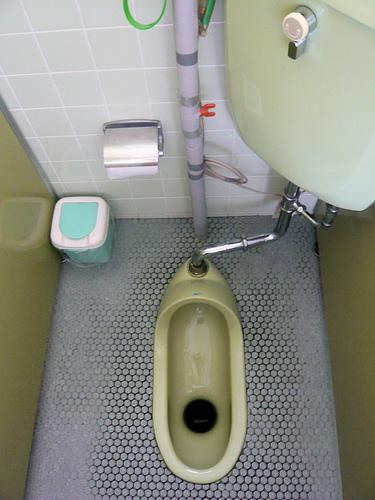Question: where is the picture taken?
Choices:
A. In a garden.
B. On the sidewalk.
C. In a bathroom.
D. In a subway tunnel.
Answer with the letter. Answer: C Question: what kind of room is pictured?
Choices:
A. Restroom.
B. Living room.
C. Dining room.
D. Kitchen.
Answer with the letter. Answer: A Question: what type of plumbing fixture is pictured?
Choices:
A. Sink.
B. Shower.
C. Bathtub.
D. Toilet.
Answer with the letter. Answer: D Question: how many pipe lines are pictured?
Choices:
A. One.
B. Two.
C. Three.
D. Four.
Answer with the letter. Answer: C 